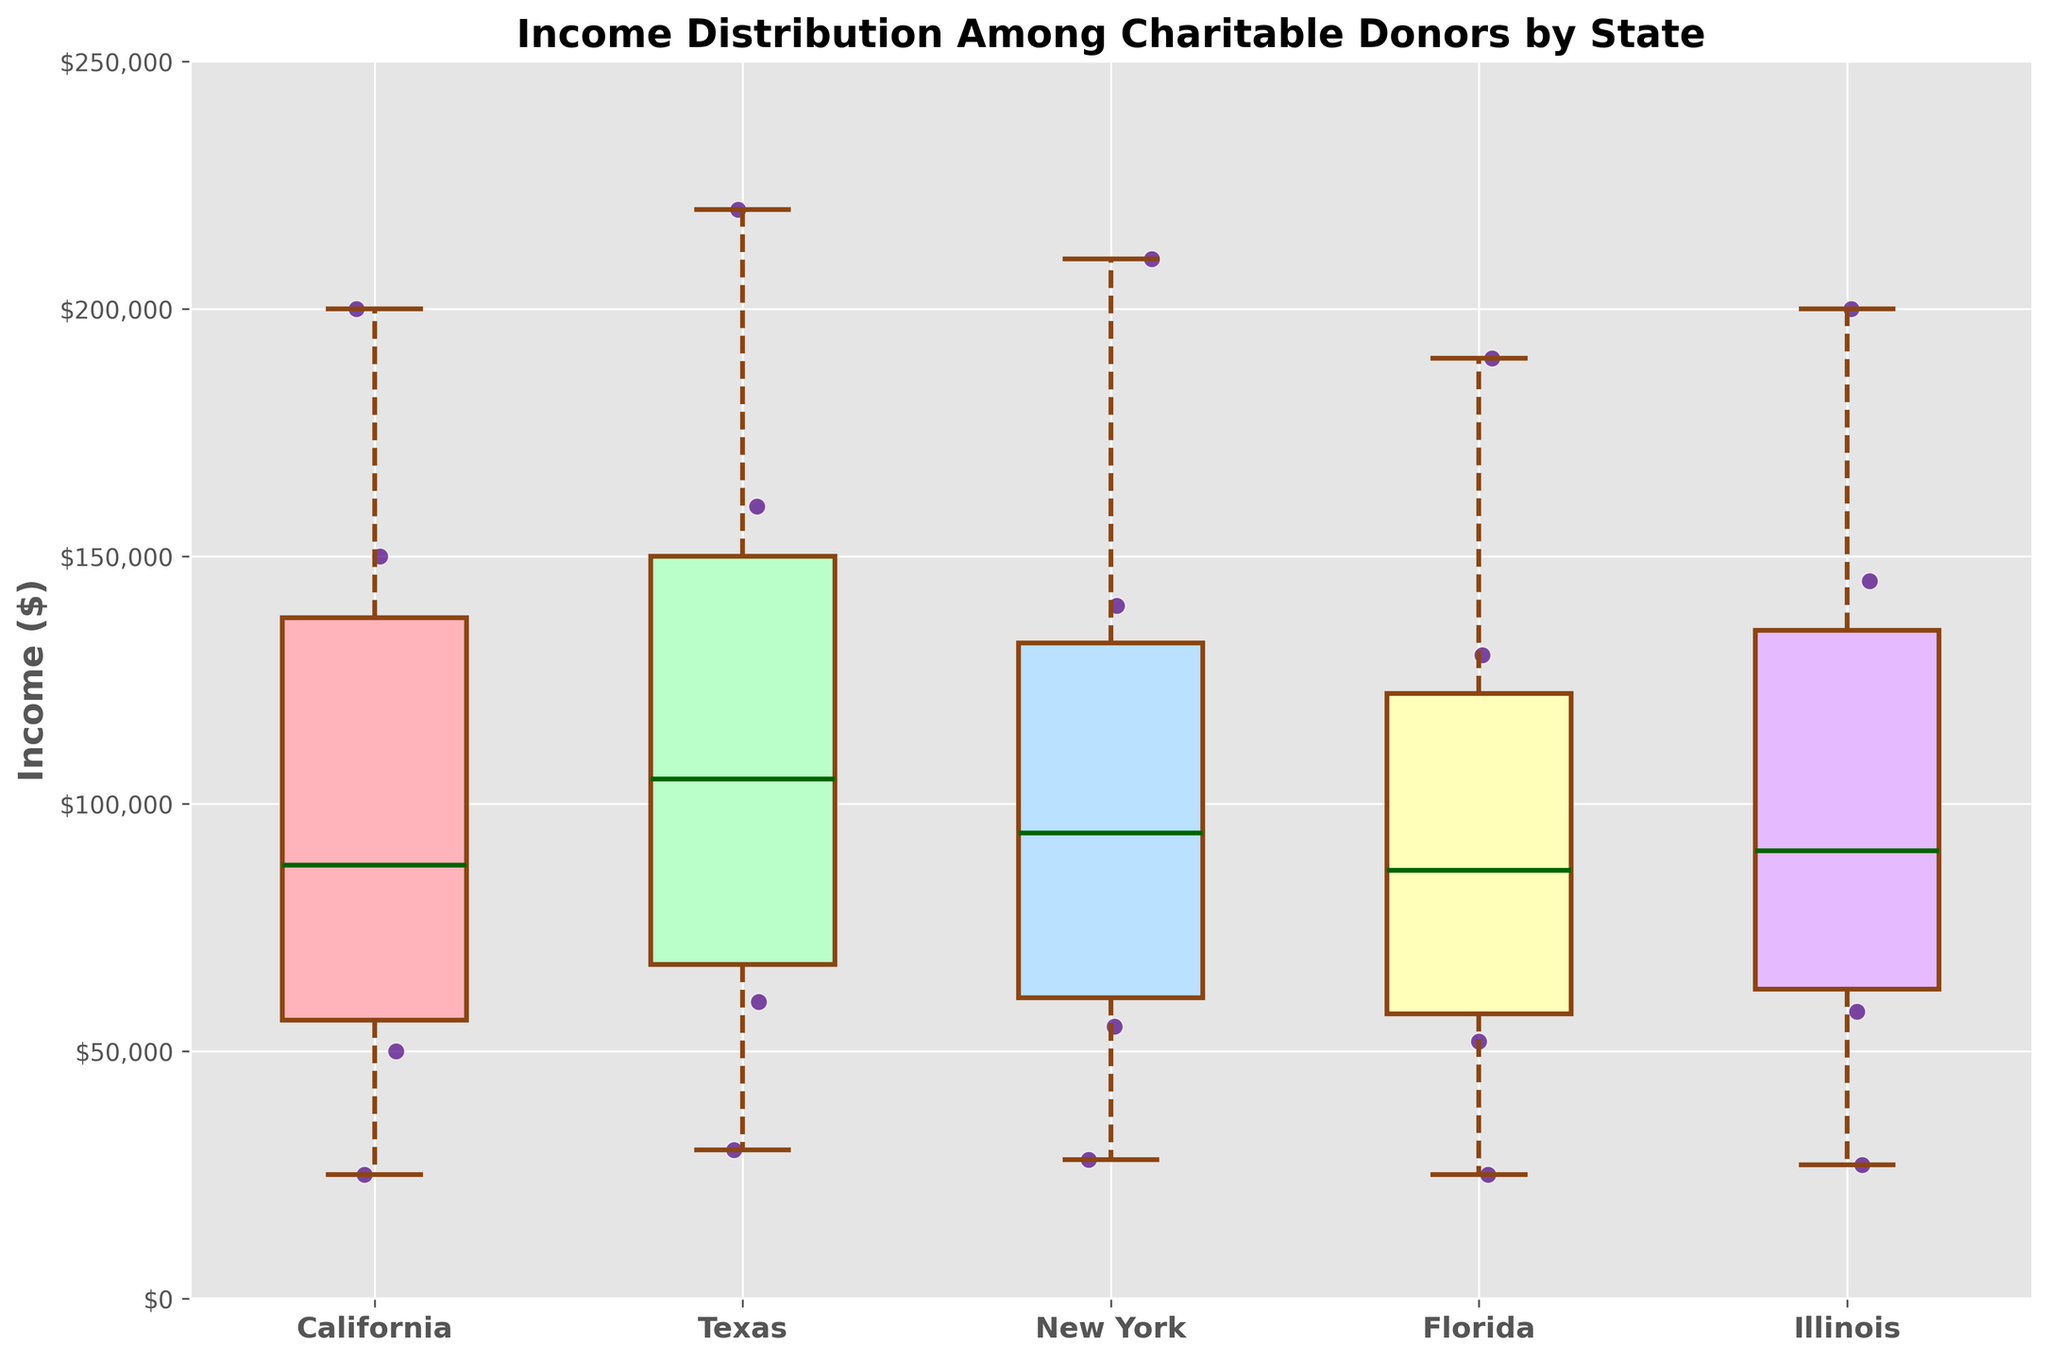What is the median income for charitable donors in Texas? The median income is the middle value when the incomes are arranged in ascending order. From the box plot, the line inside the box represents the median. In Texas, this line is around $90,000.
Answer: $90,000 How many states are presented in the box plot? The x-axis labels of the box plot indicate the states. Counting these labels reveals that there are five states on the plot.
Answer: 5 Which state has the highest maximum income among charitable donors? The maximum income is indicated by the top whisker of each box plot. The state with the highest whisker is Texas, at approximately $220,000.
Answer: Texas What can be inferred about the income distribution of charitable donors in California compared to New York? California has a wider interquartile range and higher median compared to New York. This suggests a more dispersed income distribution and generally higher income among donors in California.
Answer: California has a wider and higher distribution What is the lowest income recorded among charitable donors in Illinois? The lowest income is indicated by the bottom whisker of Illinois’ box plot. This whisker is at approximately $27,000.
Answer: $27,000 Between California and Florida, which state has a greater interquartile range (IQR) for incomes? The IQR is the distance between the first quartile (bottom of the box) and the third quartile (top of the box). California has a wider box compared to Florida, indicating a greater IQR.
Answer: California In which state is the variation in income distribution among charitable donors the smallest? The state with the smallest box (which represents the interquartile range) indicates the smallest variation. Illinois appears to have the smallest box, indicating the least variation.
Answer: Illinois How do the incomes of charitable donors in New York compare to those in Illinois? The box plots show that New York has a slightly higher median and similar overall income range compared to Illinois. Both states have closely matching whisker lengths but New York shows slightly higher incomes.
Answer: New York has slightly higher median incomes Which state shows outliers in incomes among its charitable donors? Outliers are typically shown as individual points outside the whiskers of the box plot. In this plot, none of the states show such outliers explicitly outside the whiskers.
Answer: No outliers What is the general trend in income distribution among the states presented? Observing all states' box plots, most states show a significant middle-range income distribution while Texas shows higher median and maximum incomes. The general trend shows that Texas and California have higher incomes compared to the other states.
Answer: Higher incomes in Texas and California 